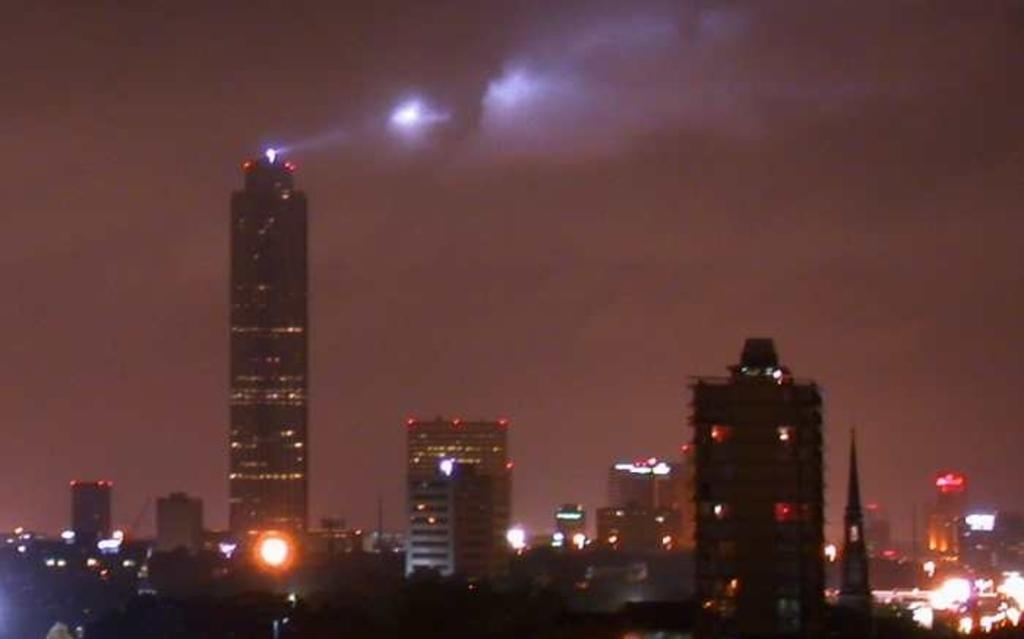What type of scene is depicted in the image? The image is a night view of a city. What structures can be seen in the image? There are buildings in the image. What part of the natural environment is visible in the image? The sky is visible in the image. What type of soup is being served in the image? There is no soup present in the image; it is a night view of a city with buildings and the sky. Can you see any yaks in the image? There are no yaks present in the image; it is a night view of a city with buildings and the sky. 